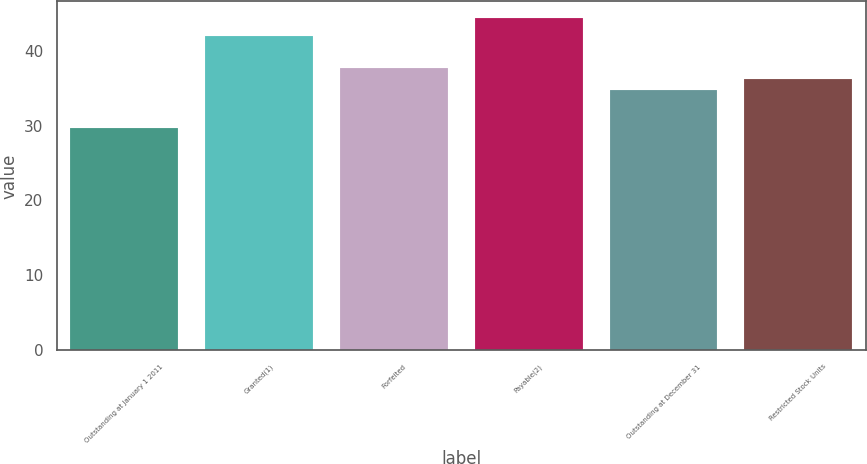Convert chart to OTSL. <chart><loc_0><loc_0><loc_500><loc_500><bar_chart><fcel>Outstanding at January 1 2011<fcel>Granted(1)<fcel>Forfeited<fcel>Payable(2)<fcel>Outstanding at December 31<fcel>Restricted Stock Units<nl><fcel>29.63<fcel>41.94<fcel>37.68<fcel>44.35<fcel>34.74<fcel>36.21<nl></chart> 